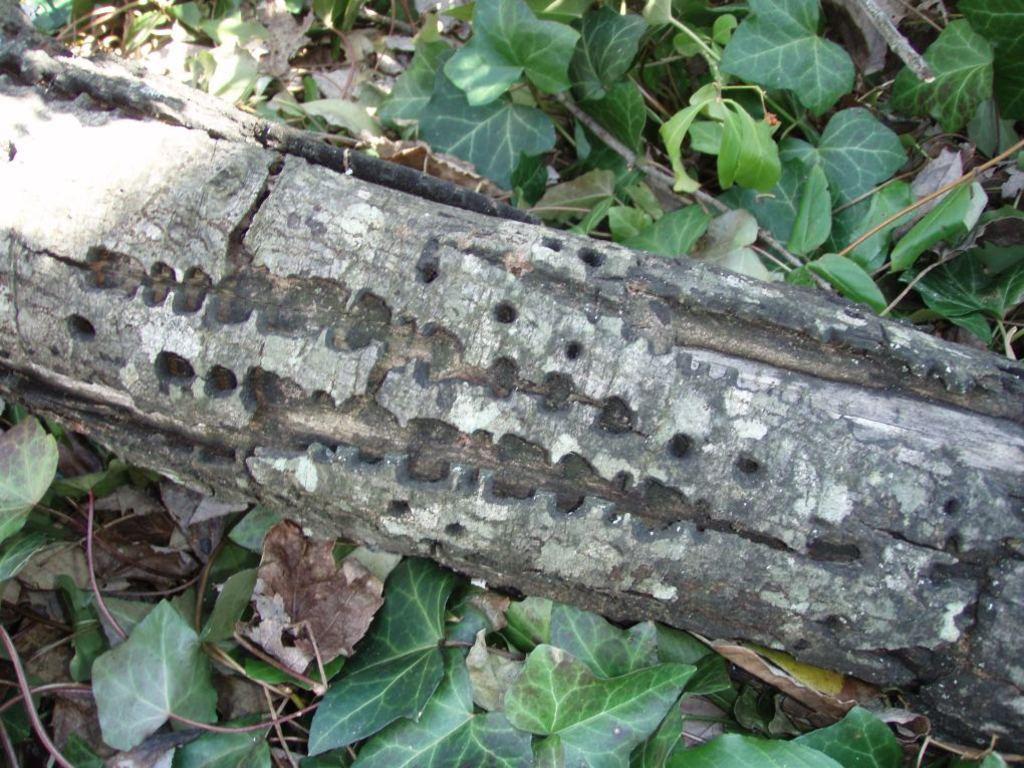How would you summarize this image in a sentence or two? In the center of the image we can see a log and there are leaves. 